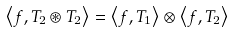Convert formula to latex. <formula><loc_0><loc_0><loc_500><loc_500>\left \langle f , T _ { 2 } \circledast T _ { 2 } \right \rangle = \left \langle f , T _ { 1 } \right \rangle \otimes \left \langle f , T _ { 2 } \right \rangle</formula> 